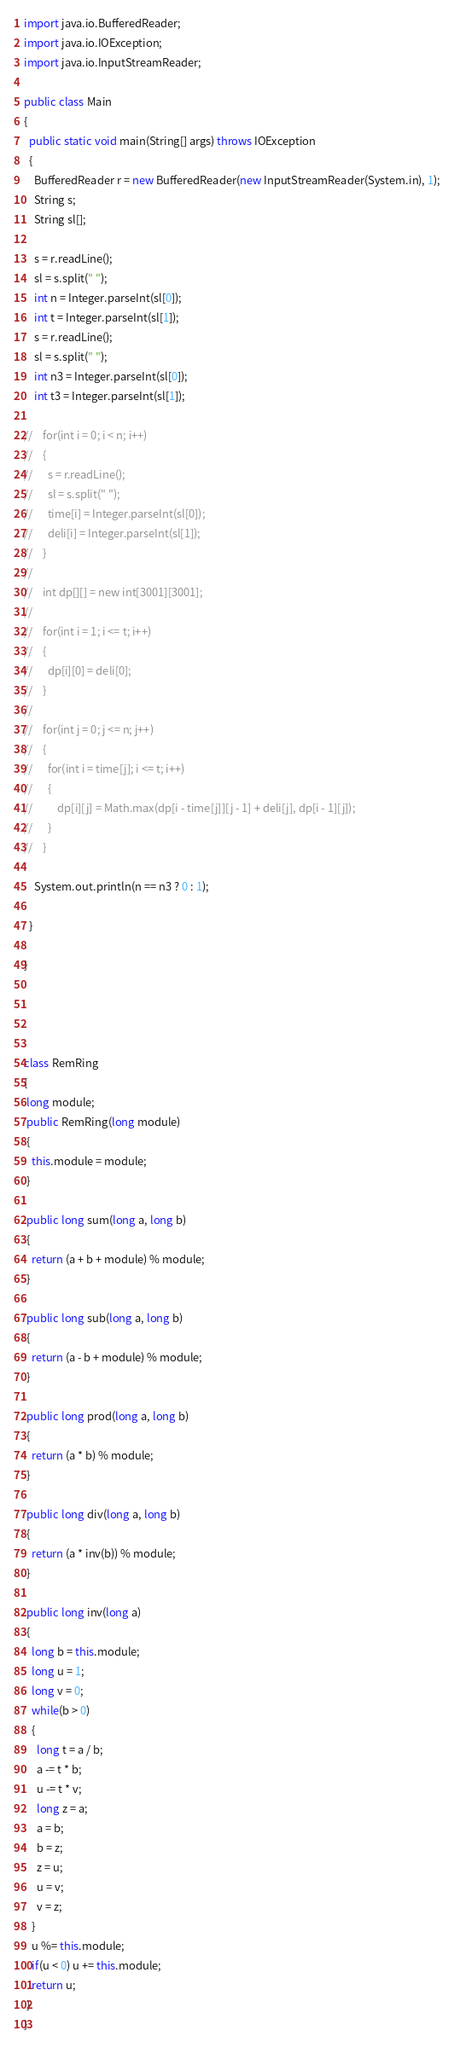Convert code to text. <code><loc_0><loc_0><loc_500><loc_500><_Java_>import java.io.BufferedReader;
import java.io.IOException;
import java.io.InputStreamReader;

public class Main
{
  public static void main(String[] args) throws IOException
  {
    BufferedReader r = new BufferedReader(new InputStreamReader(System.in), 1);
    String s;
    String sl[];

    s = r.readLine();
    sl = s.split(" ");
    int n = Integer.parseInt(sl[0]);
    int t = Integer.parseInt(sl[1]);
    s = r.readLine();
    sl = s.split(" ");
    int n3 = Integer.parseInt(sl[0]);
    int t3 = Integer.parseInt(sl[1]);

//    for(int i = 0; i < n; i++)
//    {
//      s = r.readLine();
//      sl = s.split(" ");
//      time[i] = Integer.parseInt(sl[0]);
//      deli[i] = Integer.parseInt(sl[1]);
//    }
//
//    int dp[][] = new int[3001][3001];
//
//    for(int i = 1; i <= t; i++)
//    {
//      dp[i][0] = deli[0];
//    }
//
//    for(int j = 0; j <= n; j++)
//    {
//      for(int i = time[j]; i <= t; i++)
//      {
//          dp[i][j] = Math.max(dp[i - time[j]][j - 1] + deli[j], dp[i - 1][j]);
//      }
//    }

    System.out.println(n == n3 ? 0 : 1);

  }

}




class RemRing
{
 long module;
 public RemRing(long module)
 {
   this.module = module;
 }

 public long sum(long a, long b)
 {
   return (a + b + module) % module;
 }

 public long sub(long a, long b)
 {
   return (a - b + module) % module;
 }

 public long prod(long a, long b)
 {
   return (a * b) % module;
 }

 public long div(long a, long b)
 {
   return (a * inv(b)) % module;
 }

 public long inv(long a)
 {
   long b = this.module;
   long u = 1;
   long v = 0;
   while(b > 0)
   {
     long t = a / b;
     a -= t * b;
     u -= t * v;
     long z = a;
     a = b;
     b = z;
     z = u;
     u = v;
     v = z;
   }
   u %= this.module;
   if(u < 0) u += this.module;
   return u;
 }
}</code> 